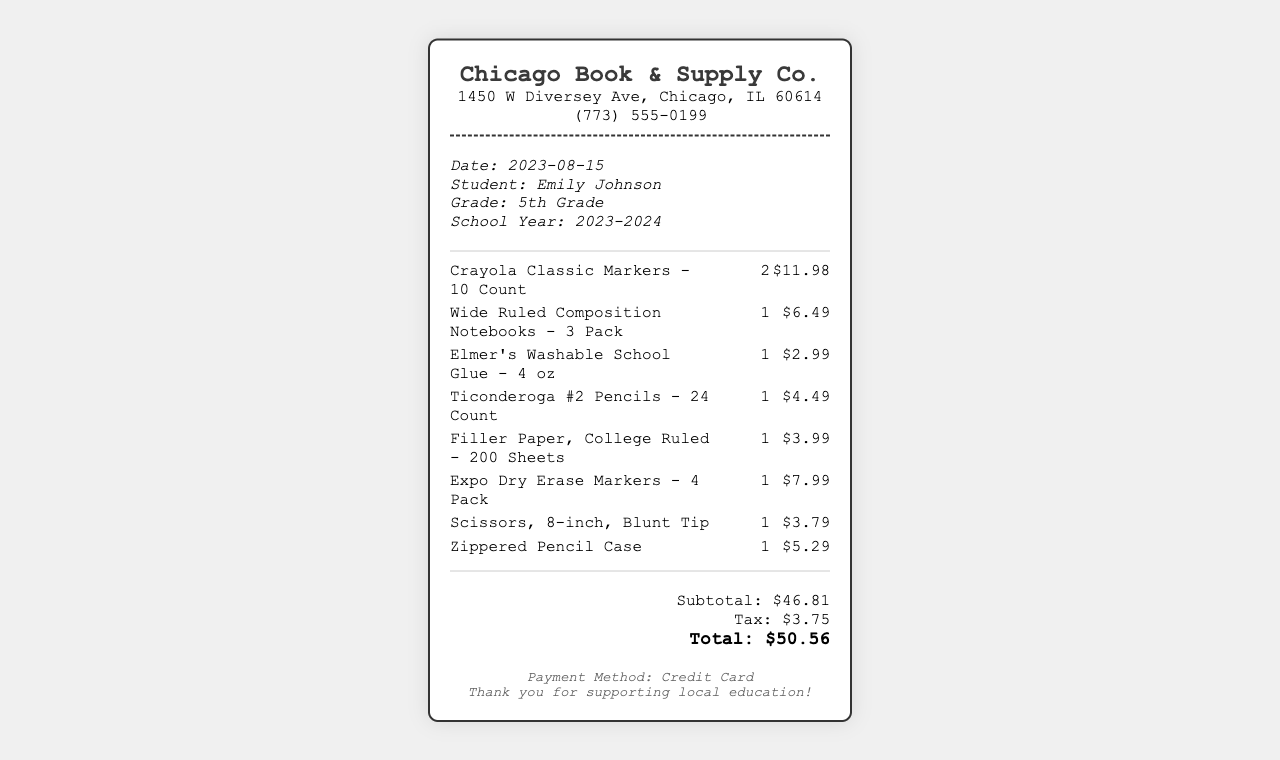What is the date of the purchase? The date of the purchase is displayed at the top of the receipt under student information.
Answer: 2023-08-15 What is the name of the store? The name of the store is prominently featured at the top of the receipt.
Answer: Chicago Book & Supply Co How many packs of composition notebooks were bought? The quantity of composition notebooks is listed next to its description in the items section.
Answer: 1 What is the total amount spent? The total amount spent is calculated and listed as the final amount after taxes in the totals section.
Answer: $50.56 How many items were purchased in total? The total number of items can be calculated by adding up the quantities listed in the receipt.
Answer: 8 What is the price of the Crayola Classic Markers? The price of the Crayola Classic Markers is listed next to the item description in the items section.
Answer: $11.98 What type of payment was used? The payment method is mentioned in the notes section at the bottom of the receipt.
Answer: Credit Card Which grade is Emily Johnson in? Emily's grade is specified in the student information section of the receipt.
Answer: 5th Grade What is the tax amount charged? The tax amount is shown in the totals section, clearly itemized under subtotal.
Answer: $3.75 